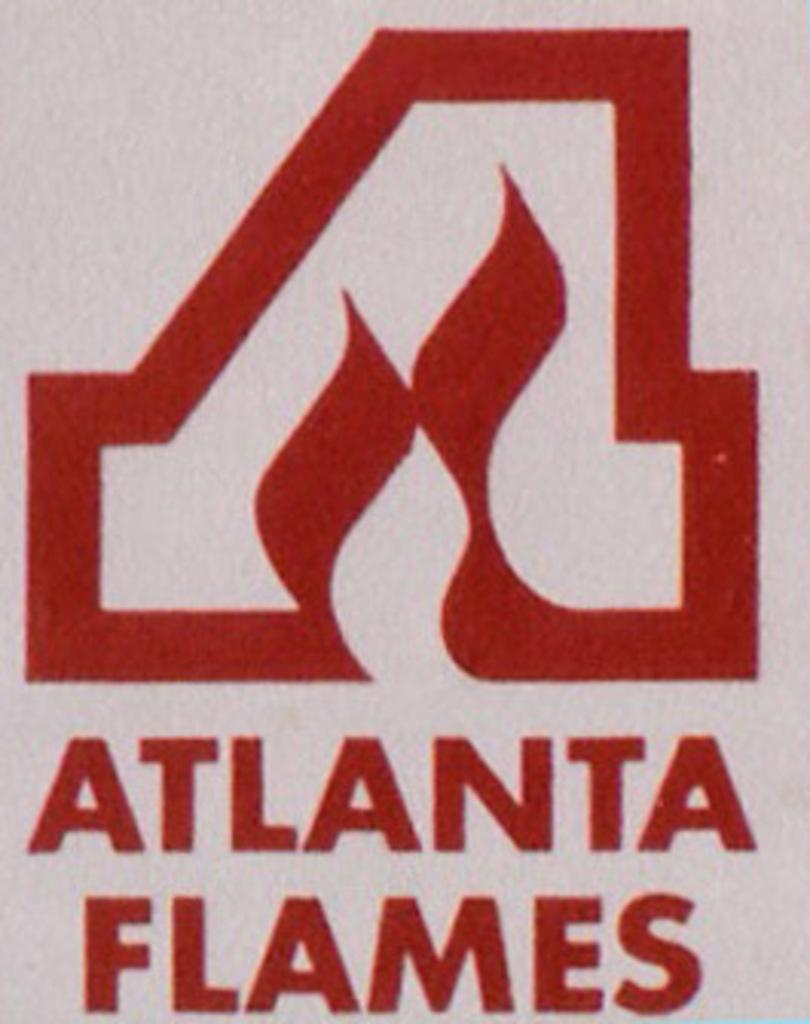Provide a one-sentence caption for the provided image. A stylized A appears above the words Atlanta Flames. 